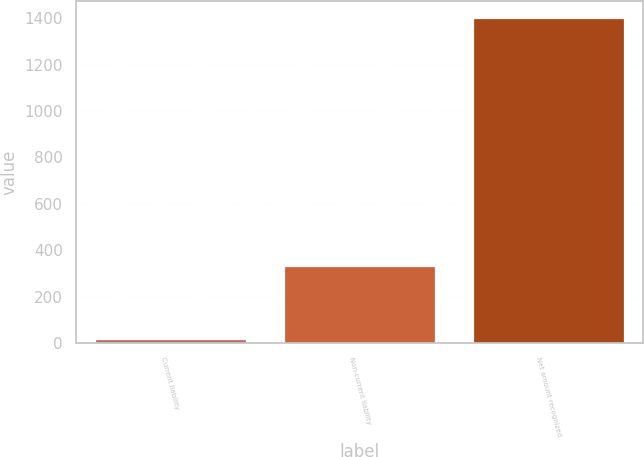Convert chart. <chart><loc_0><loc_0><loc_500><loc_500><bar_chart><fcel>Current liability<fcel>Non-current liability<fcel>Net amount recognized<nl><fcel>18<fcel>330<fcel>1403<nl></chart> 